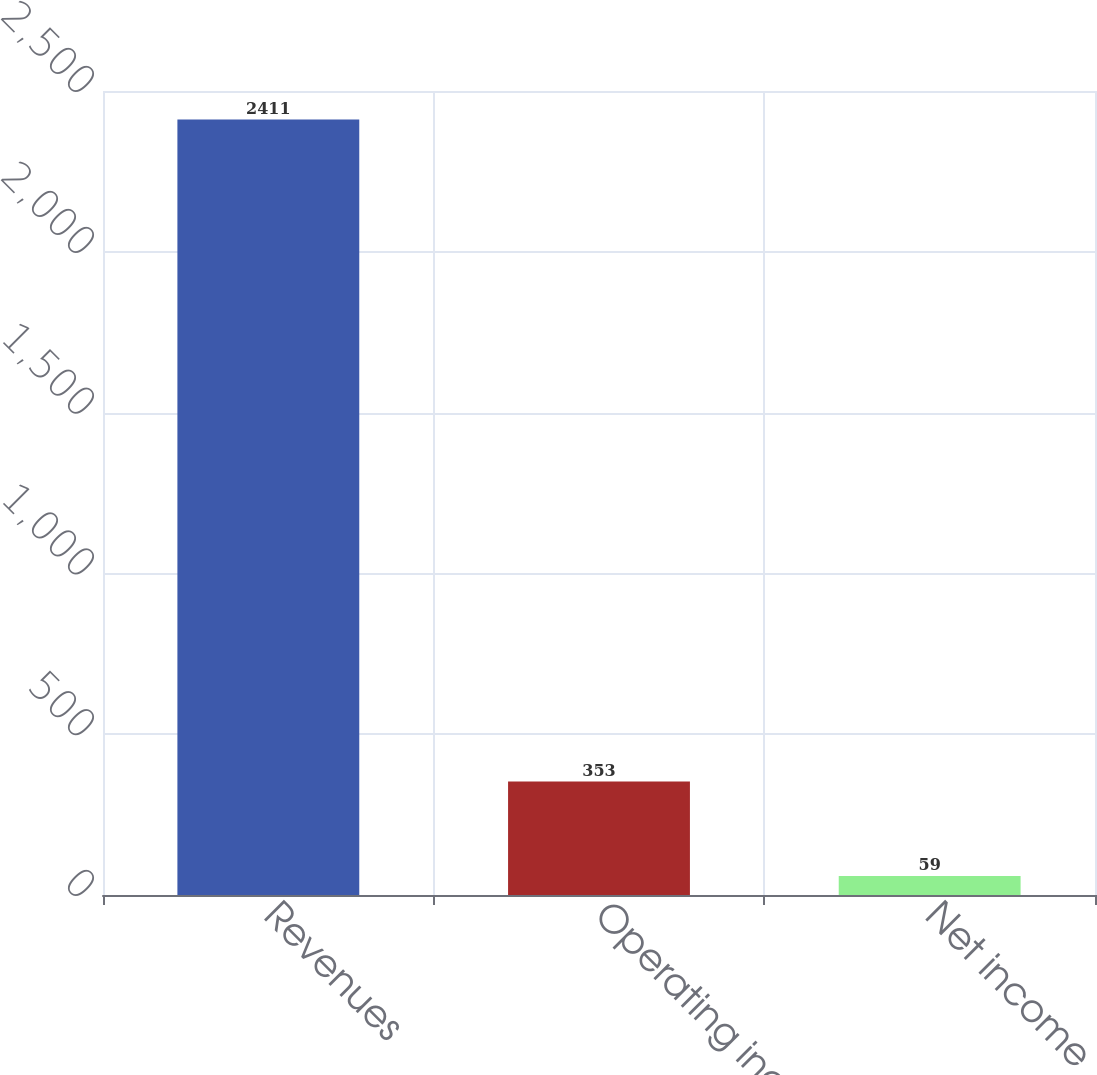Convert chart to OTSL. <chart><loc_0><loc_0><loc_500><loc_500><bar_chart><fcel>Revenues<fcel>Operating income (a)<fcel>Net income<nl><fcel>2411<fcel>353<fcel>59<nl></chart> 